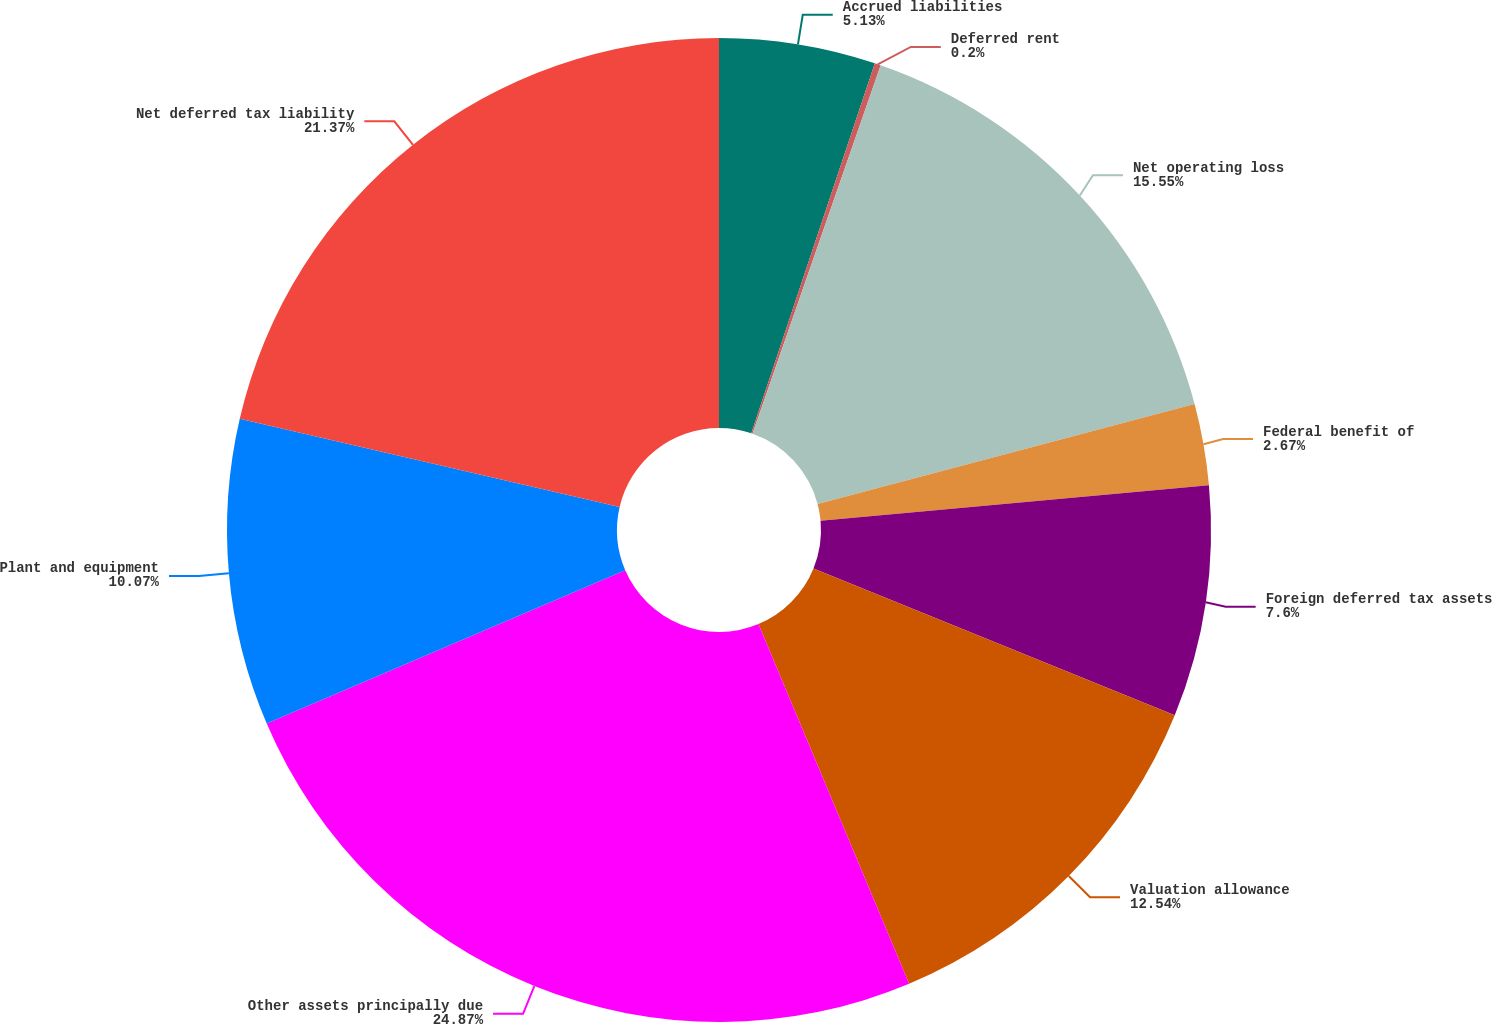<chart> <loc_0><loc_0><loc_500><loc_500><pie_chart><fcel>Accrued liabilities<fcel>Deferred rent<fcel>Net operating loss<fcel>Federal benefit of<fcel>Foreign deferred tax assets<fcel>Valuation allowance<fcel>Other assets principally due<fcel>Plant and equipment<fcel>Net deferred tax liability<nl><fcel>5.13%<fcel>0.2%<fcel>15.55%<fcel>2.67%<fcel>7.6%<fcel>12.54%<fcel>24.88%<fcel>10.07%<fcel>21.37%<nl></chart> 